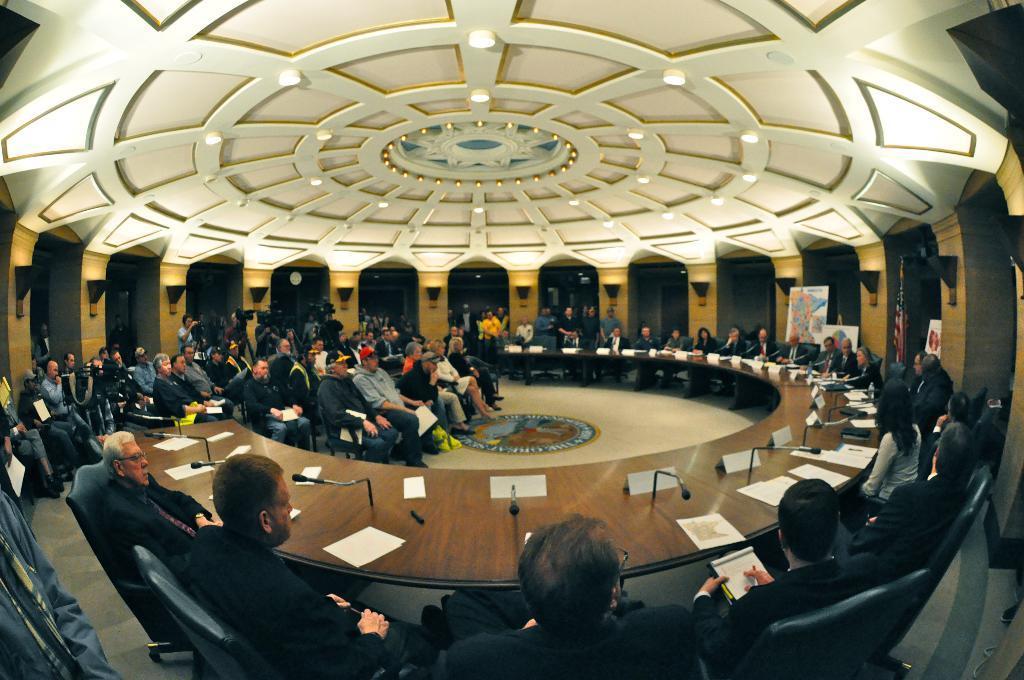Please provide a concise description of this image. This picture shows few people seated on the chairs and we see papers and microphones on the table and we see lights to the ceiling and a map and we see few people holding papers in their hands and we see a flagpole. 